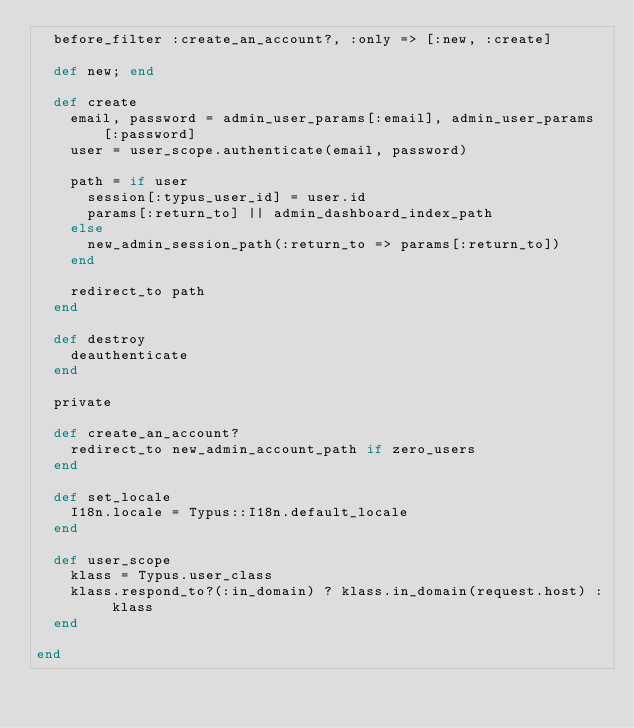<code> <loc_0><loc_0><loc_500><loc_500><_Ruby_>  before_filter :create_an_account?, :only => [:new, :create]

  def new; end

  def create
    email, password = admin_user_params[:email], admin_user_params[:password]
    user = user_scope.authenticate(email, password)

    path = if user
      session[:typus_user_id] = user.id
      params[:return_to] || admin_dashboard_index_path
    else
      new_admin_session_path(:return_to => params[:return_to])
    end

    redirect_to path
  end

  def destroy
    deauthenticate
  end

  private

  def create_an_account?
    redirect_to new_admin_account_path if zero_users
  end

  def set_locale
    I18n.locale = Typus::I18n.default_locale
  end

  def user_scope
    klass = Typus.user_class
    klass.respond_to?(:in_domain) ? klass.in_domain(request.host) : klass
  end

end
</code> 